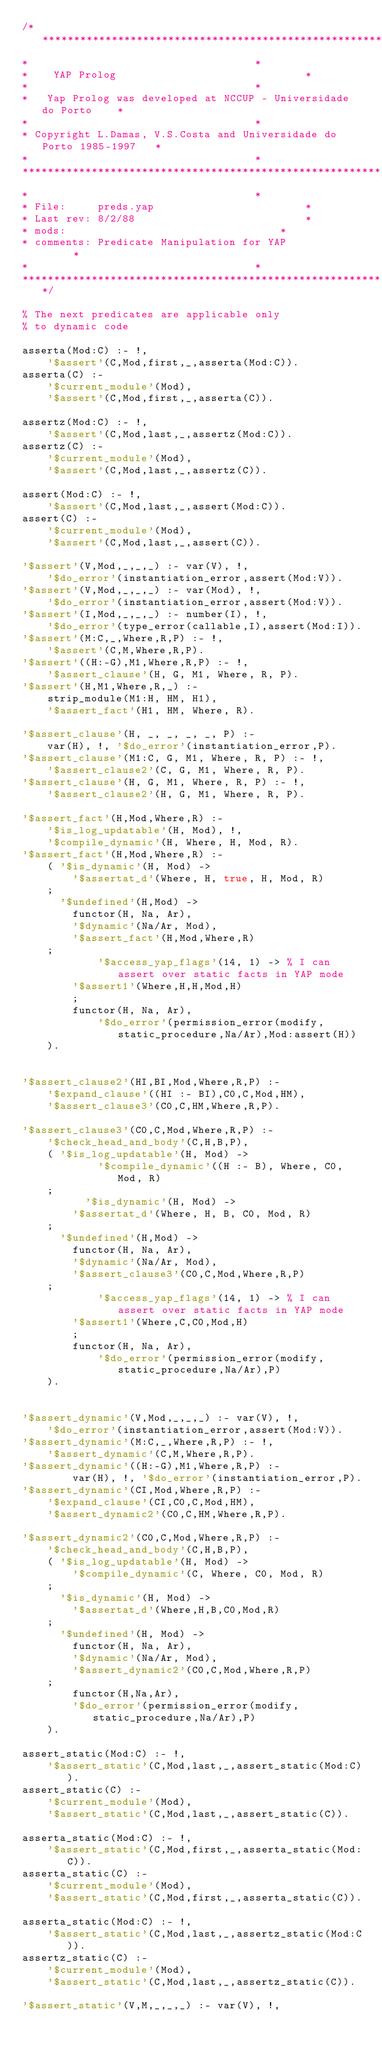<code> <loc_0><loc_0><loc_500><loc_500><_Prolog_>/*************************************************************************
*									 *
*	 YAP Prolog 							 *
*									 *
*	Yap Prolog was developed at NCCUP - Universidade do Porto	 *
*									 *
* Copyright L.Damas, V.S.Costa and Universidade do Porto 1985-1997	 *
*									 *
**************************************************************************
*									 *
* File:		preds.yap						 *
* Last rev:	8/2/88							 *
* mods:									 *
* comments:	Predicate Manipulation for YAP				 *
*									 *
*************************************************************************/

% The next predicates are applicable only
% to dynamic code

asserta(Mod:C) :- !,
	'$assert'(C,Mod,first,_,asserta(Mod:C)).
asserta(C) :-
	'$current_module'(Mod),
	'$assert'(C,Mod,first,_,asserta(C)).

assertz(Mod:C) :- !,
	'$assert'(C,Mod,last,_,assertz(Mod:C)).
assertz(C) :-
	'$current_module'(Mod),
	'$assert'(C,Mod,last,_,assertz(C)).

assert(Mod:C) :- !,
	'$assert'(C,Mod,last,_,assert(Mod:C)).
assert(C) :-
	'$current_module'(Mod),
	'$assert'(C,Mod,last,_,assert(C)).

'$assert'(V,Mod,_,_,_) :- var(V), !,
	'$do_error'(instantiation_error,assert(Mod:V)).
'$assert'(V,Mod,_,_,_) :- var(Mod), !,
	'$do_error'(instantiation_error,assert(Mod:V)).
'$assert'(I,Mod,_,_,_) :- number(I), !,
	'$do_error'(type_error(callable,I),assert(Mod:I)).
'$assert'(M:C,_,Where,R,P) :- !,
	'$assert'(C,M,Where,R,P).
'$assert'((H:-G),M1,Where,R,P) :- !,
	'$assert_clause'(H, G, M1, Where, R, P).
'$assert'(H,M1,Where,R,_) :-
	strip_module(M1:H, HM, H1),
	'$assert_fact'(H1, HM, Where, R).

'$assert_clause'(H, _, _, _, _, P) :-
	var(H), !, '$do_error'(instantiation_error,P).
'$assert_clause'(M1:C, G, M1, Where, R, P) :- !,
	'$assert_clause2'(C, G, M1, Where, R, P).
'$assert_clause'(H, G, M1, Where, R, P) :- !,
	'$assert_clause2'(H, G, M1, Where, R, P).

'$assert_fact'(H,Mod,Where,R) :-
	'$is_log_updatable'(H, Mod), !,
	'$compile_dynamic'(H, Where, H, Mod, R).
'$assert_fact'(H,Mod,Where,R) :-
	( '$is_dynamic'(H, Mod) ->
	    '$assertat_d'(Where, H, true, H, Mod, R)
	;
	  '$undefined'(H,Mod) -> 
	    functor(H, Na, Ar),
	    '$dynamic'(Na/Ar, Mod),
	    '$assert_fact'(H,Mod,Where,R)
	;
            '$access_yap_flags'(14, 1) -> % I can assert over static facts in YAP mode
	    '$assert1'(Where,H,H,Mod,H)
        ;
	    functor(H, Na, Ar),
            '$do_error'(permission_error(modify,static_procedure,Na/Ar),Mod:assert(H))
	).


'$assert_clause2'(HI,BI,Mod,Where,R,P) :-
	'$expand_clause'((HI :- BI),C0,C,Mod,HM),
	'$assert_clause3'(C0,C,HM,Where,R,P).

'$assert_clause3'(C0,C,Mod,Where,R,P) :-
	'$check_head_and_body'(C,H,B,P),
	( '$is_log_updatable'(H, Mod) ->
            '$compile_dynamic'((H :- B), Where, C0, Mod, R)
	;
          '$is_dynamic'(H, Mod) ->
	    '$assertat_d'(Where, H, B, C0, Mod, R)
	;
	  '$undefined'(H,Mod) -> 
	    functor(H, Na, Ar),
	    '$dynamic'(Na/Ar, Mod),
	    '$assert_clause3'(C0,C,Mod,Where,R,P)
	;
            '$access_yap_flags'(14, 1) -> % I can assert over static facts in YAP mode
	    '$assert1'(Where,C,C0,Mod,H)
        ;
	    functor(H, Na, Ar),
            '$do_error'(permission_error(modify,static_procedure,Na/Ar),P)
	).


'$assert_dynamic'(V,Mod,_,_,_) :- var(V), !,
	'$do_error'(instantiation_error,assert(Mod:V)).
'$assert_dynamic'(M:C,_,Where,R,P) :- !,
	'$assert_dynamic'(C,M,Where,R,P).
'$assert_dynamic'((H:-G),M1,Where,R,P) :-
        var(H), !, '$do_error'(instantiation_error,P).
'$assert_dynamic'(CI,Mod,Where,R,P) :-
	'$expand_clause'(CI,C0,C,Mod,HM),
	'$assert_dynamic2'(C0,C,HM,Where,R,P).

'$assert_dynamic2'(C0,C,Mod,Where,R,P) :-
	'$check_head_and_body'(C,H,B,P),
	( '$is_log_updatable'(H, Mod) ->
	    '$compile_dynamic'(C, Where, C0, Mod, R)
	;
	  '$is_dynamic'(H, Mod) ->
	    '$assertat_d'(Where,H,B,C0,Mod,R)
	;
	  '$undefined'(H, Mod) -> 
	    functor(H, Na, Ar),
	    '$dynamic'(Na/Ar, Mod),
	    '$assert_dynamic2'(C0,C,Mod,Where,R,P)
	;
	    functor(H,Na,Ar),
	    '$do_error'(permission_error(modify,static_procedure,Na/Ar),P)
	).

assert_static(Mod:C) :- !,
	'$assert_static'(C,Mod,last,_,assert_static(Mod:C)).
assert_static(C) :-
	'$current_module'(Mod),
	'$assert_static'(C,Mod,last,_,assert_static(C)).

asserta_static(Mod:C) :- !,
	'$assert_static'(C,Mod,first,_,asserta_static(Mod:C)).
asserta_static(C) :-
	'$current_module'(Mod),
	'$assert_static'(C,Mod,first,_,asserta_static(C)).

asserta_static(Mod:C) :- !,
	'$assert_static'(C,Mod,last,_,assertz_static(Mod:C)).
assertz_static(C) :-
	'$current_module'(Mod),
	'$assert_static'(C,Mod,last,_,assertz_static(C)).

'$assert_static'(V,M,_,_,_) :- var(V), !,</code> 